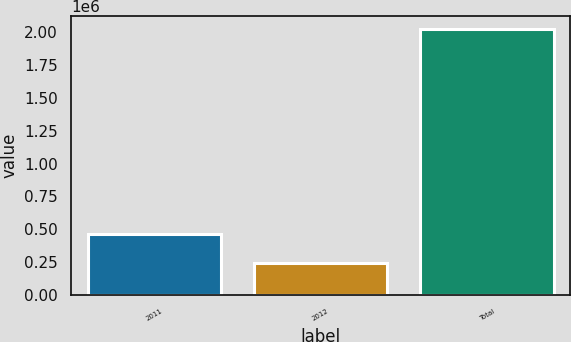Convert chart. <chart><loc_0><loc_0><loc_500><loc_500><bar_chart><fcel>2011<fcel>2012<fcel>Total<nl><fcel>466470<fcel>244418<fcel>2.02273e+06<nl></chart> 